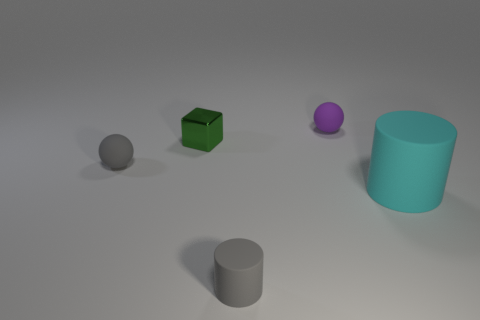Subtract all cyan cylinders. How many cylinders are left? 1 Add 1 tiny cylinders. How many objects exist? 6 Subtract all balls. How many objects are left? 3 Subtract 1 spheres. How many spheres are left? 1 Subtract all cyan blocks. Subtract all cyan cylinders. How many blocks are left? 1 Subtract all red blocks. How many gray spheres are left? 1 Subtract all brown rubber cylinders. Subtract all gray spheres. How many objects are left? 4 Add 3 large rubber cylinders. How many large rubber cylinders are left? 4 Add 1 cyan cylinders. How many cyan cylinders exist? 2 Subtract 0 yellow cubes. How many objects are left? 5 